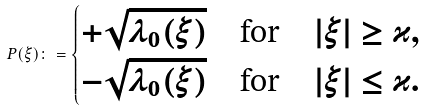Convert formula to latex. <formula><loc_0><loc_0><loc_500><loc_500>P ( \xi ) \colon = \begin{cases} + \sqrt { \lambda _ { 0 } ( \xi ) } \quad \text {for} \quad | \xi | \geq \varkappa , \\ - \sqrt { \lambda _ { 0 } ( \xi ) } \quad \text {for} \quad | \xi | \leq \varkappa . \end{cases}</formula> 